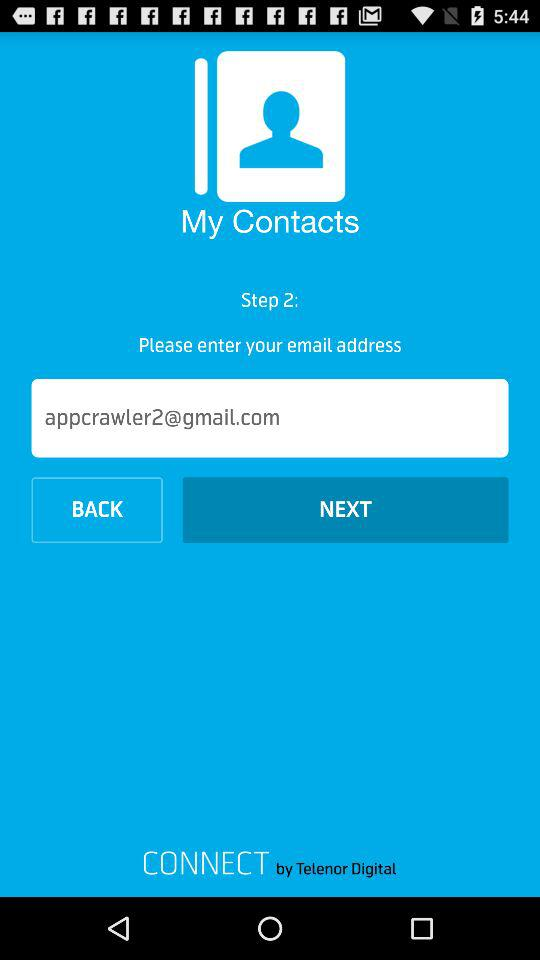What is the entered email address? The entered email address is appcrawler2@gmail.com. 